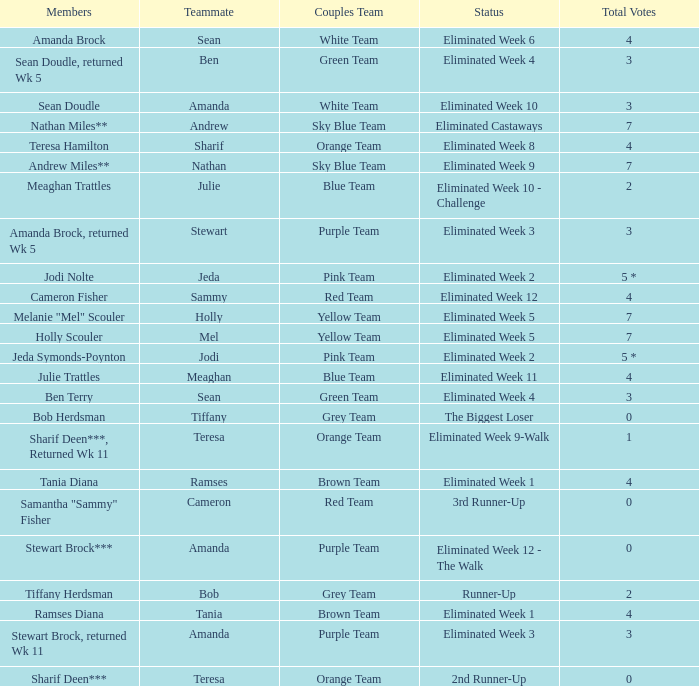What were Holly Scouler's total votes? 7.0. 